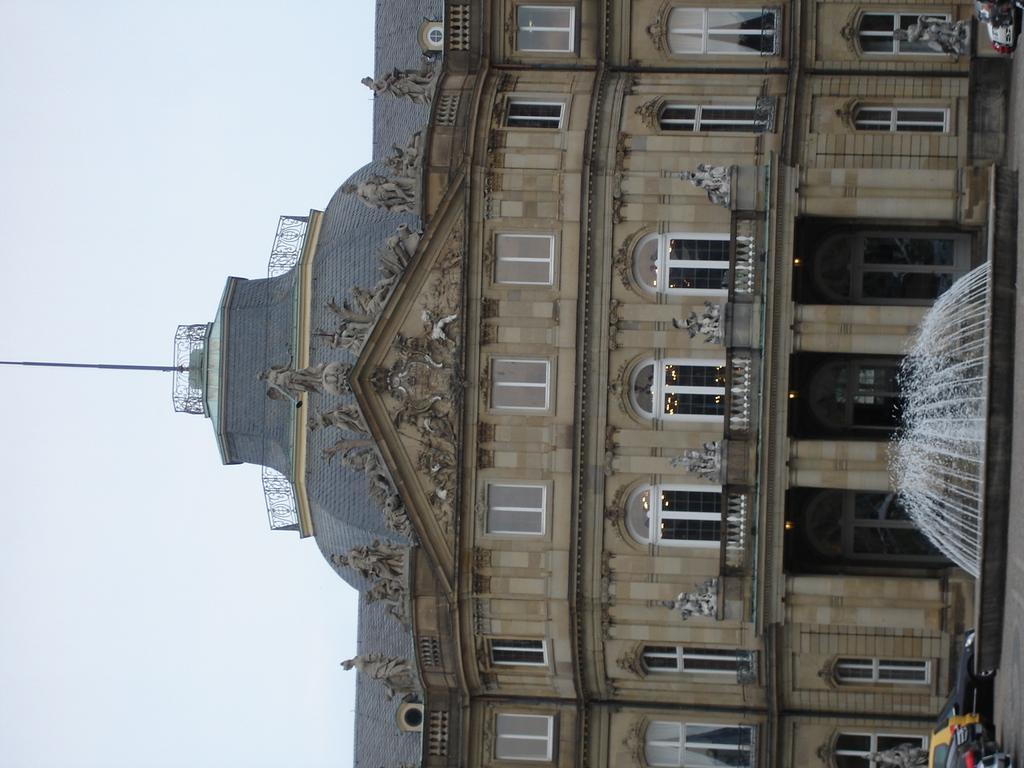Could you give a brief overview of what you see in this image? In this picture there is a building on the right side of the image, on which there are windows and there is a fountain and cars in front of it. 